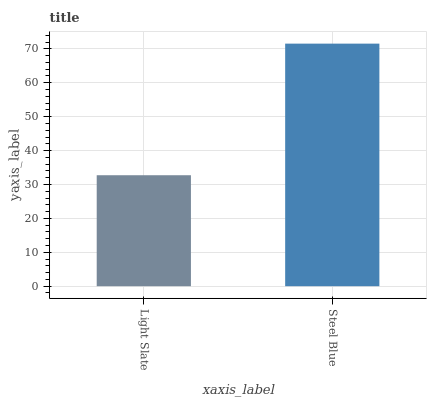Is Light Slate the minimum?
Answer yes or no. Yes. Is Steel Blue the maximum?
Answer yes or no. Yes. Is Steel Blue the minimum?
Answer yes or no. No. Is Steel Blue greater than Light Slate?
Answer yes or no. Yes. Is Light Slate less than Steel Blue?
Answer yes or no. Yes. Is Light Slate greater than Steel Blue?
Answer yes or no. No. Is Steel Blue less than Light Slate?
Answer yes or no. No. Is Steel Blue the high median?
Answer yes or no. Yes. Is Light Slate the low median?
Answer yes or no. Yes. Is Light Slate the high median?
Answer yes or no. No. Is Steel Blue the low median?
Answer yes or no. No. 